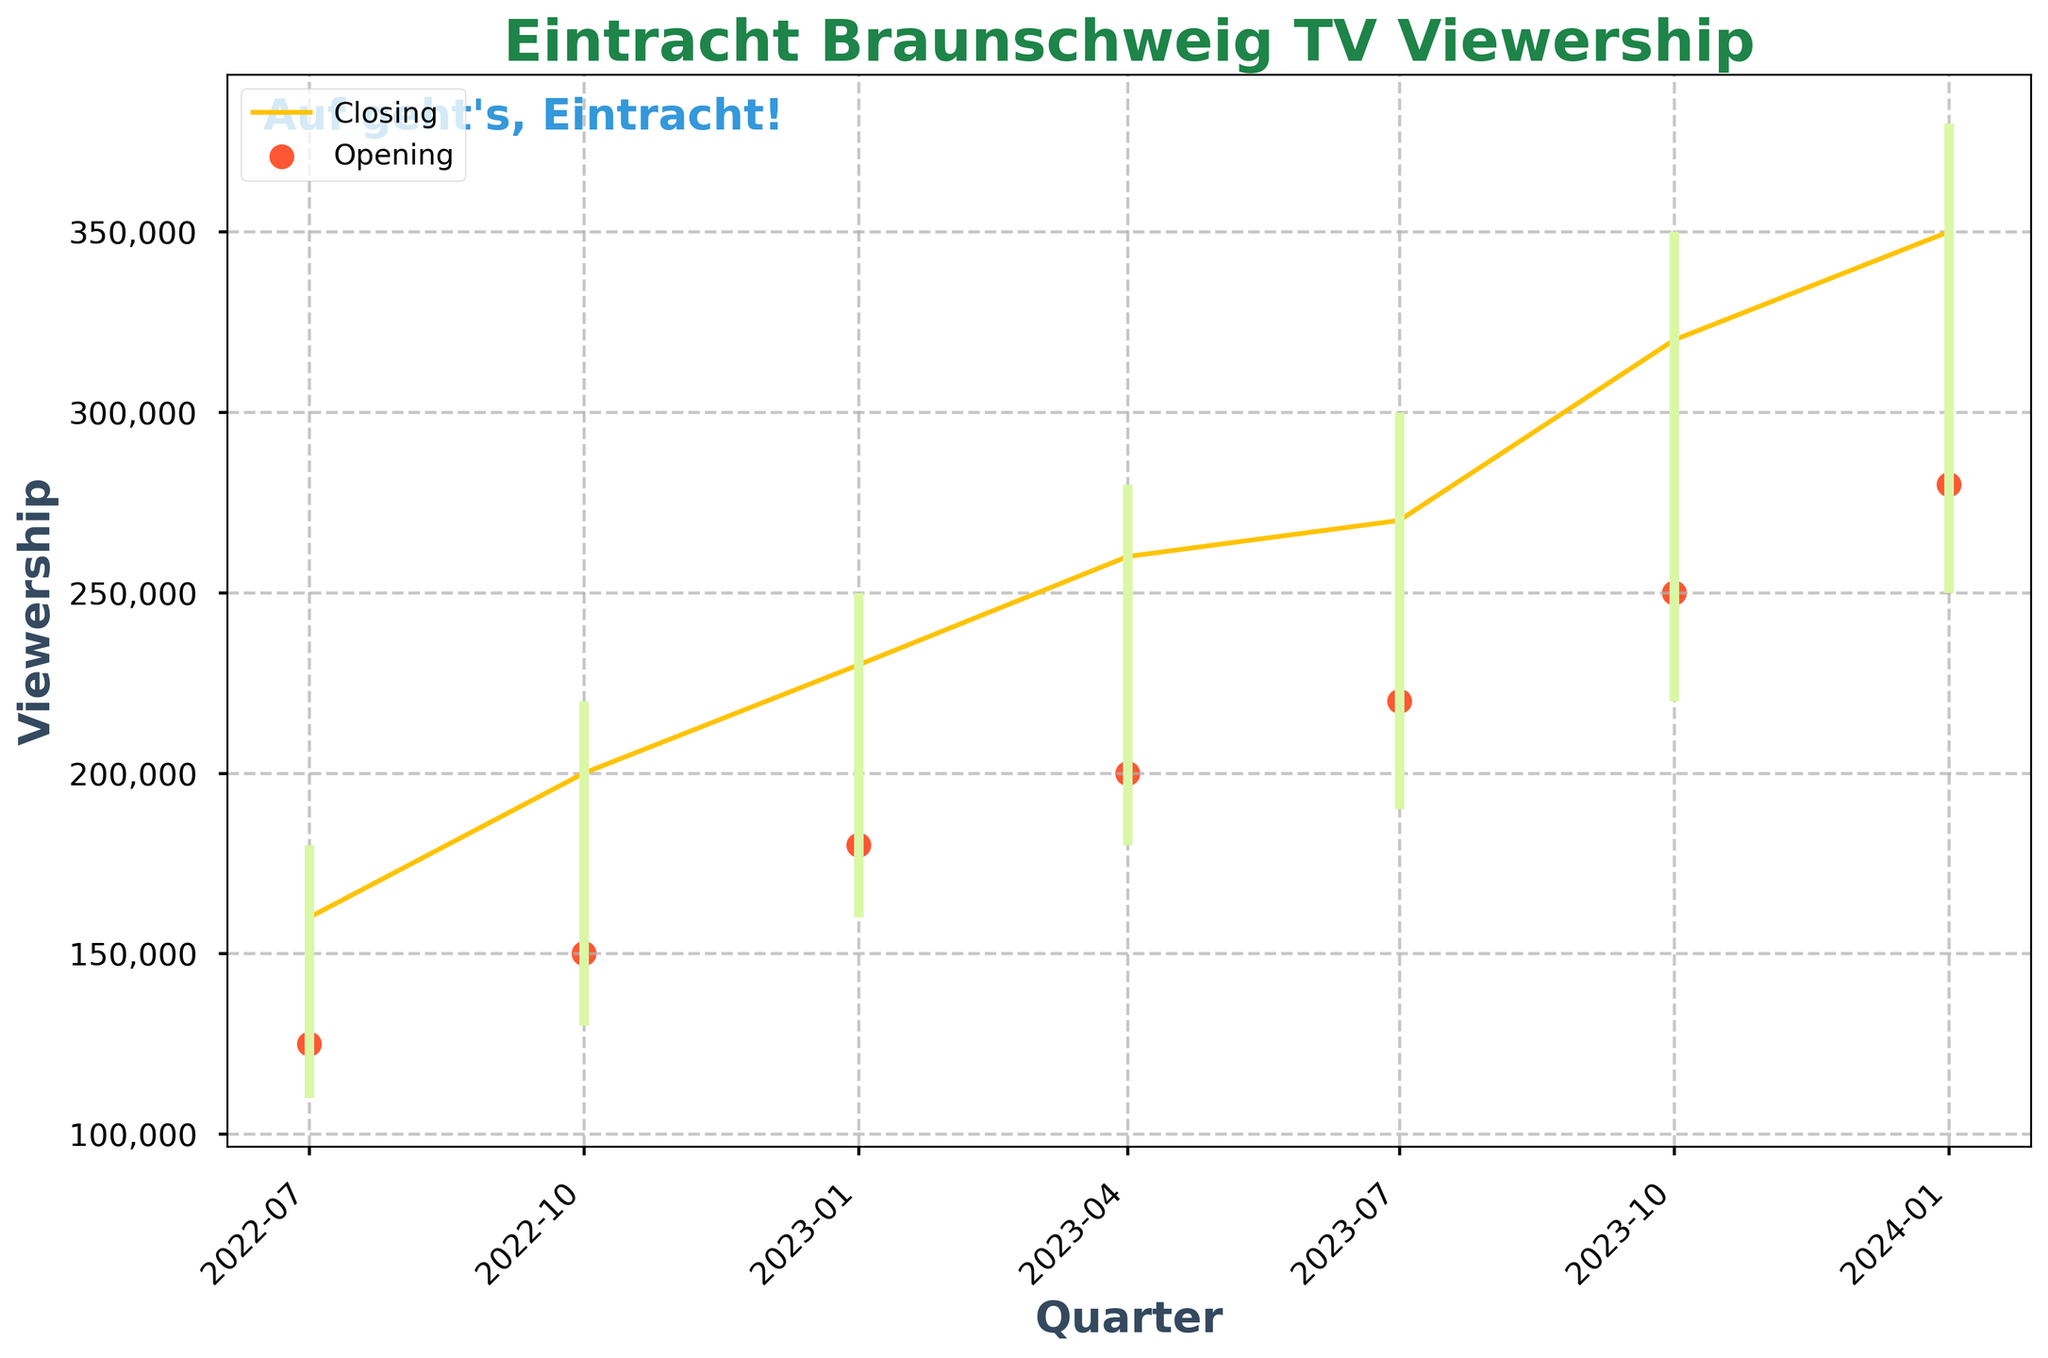How many quarters are displayed in the figure? Count the number of data points on the x-axis.
Answer: 7 What is the highest recorded viewership peak, and in which quarter did it occur? Look at the highest peak from the High column and see which quarter it aligns with. The highest peak is 380,000 in Q1 2024.
Answer: 380,000 in Q1 2024 What is the title of the figure? Read the title displayed at the top of the figure.
Answer: Eintracht Braunschweig TV Viewership Which quarter has the lowest closing viewership? Find the lowest value in the Closing column and identify the associated quarter. The lowest closing viewership is 160,000 in Q3 2022.
Answer: Q3 2022 What's the difference between the opening viewership in Q3 2023 and its closing viewership? Subtract the opening viewership value of Q3 2023 from its closing viewership value: 270,000 - 220,000 = 50,000.
Answer: 50,000 Did the closing viewership increase or decrease from Q4 2022 to Q1 2023? Compare the closing values for Q4 2022 (200,000) and Q1 2023 (230,000). 230,000 is greater than 200,000, meaning it increased.
Answer: Increased In which quarter did the viewership see the biggest single-quarter peak? Compare all peaks (High values) from one quarter to the next and find the quarter with the largest increase. The biggest increase is from Q4 2023 to Q1 2024 (350,000 to 380,000).
Answer: Q1 2024 Which quarter had a lower opening viewership, Q4 2022 or Q1 2023? Compare the Opening values for Q4 2022 (150,000) and Q1 2023 (180,000). Q4 2022 has a lower opening viewership.
Answer: Q4 2022 By how much did the low viewership increase from Q2 2023 to Q3 2023? Subtract the Low value of Q2 2023 from the Low value of Q3 2023: 190,000 - 180,000 = 10,000.
Answer: 10,000 